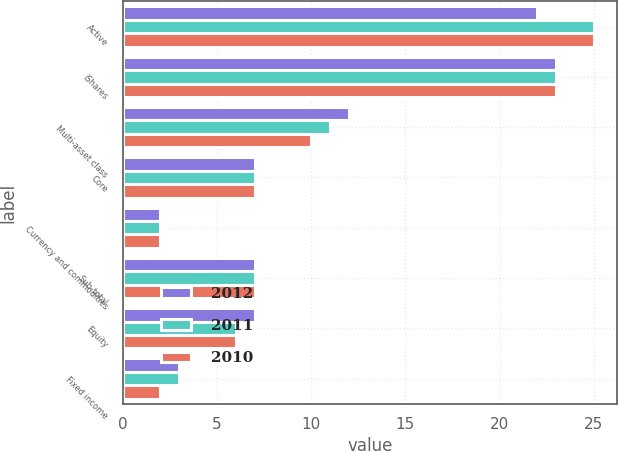<chart> <loc_0><loc_0><loc_500><loc_500><stacked_bar_chart><ecel><fcel>Active<fcel>iShares<fcel>Multi-asset class<fcel>Core<fcel>Currency and commodities<fcel>Sub-total<fcel>Equity<fcel>Fixed income<nl><fcel>2012<fcel>22<fcel>23<fcel>12<fcel>7<fcel>2<fcel>7<fcel>7<fcel>3<nl><fcel>2011<fcel>25<fcel>23<fcel>11<fcel>7<fcel>2<fcel>7<fcel>6<fcel>3<nl><fcel>2010<fcel>25<fcel>23<fcel>10<fcel>7<fcel>2<fcel>7<fcel>6<fcel>2<nl></chart> 